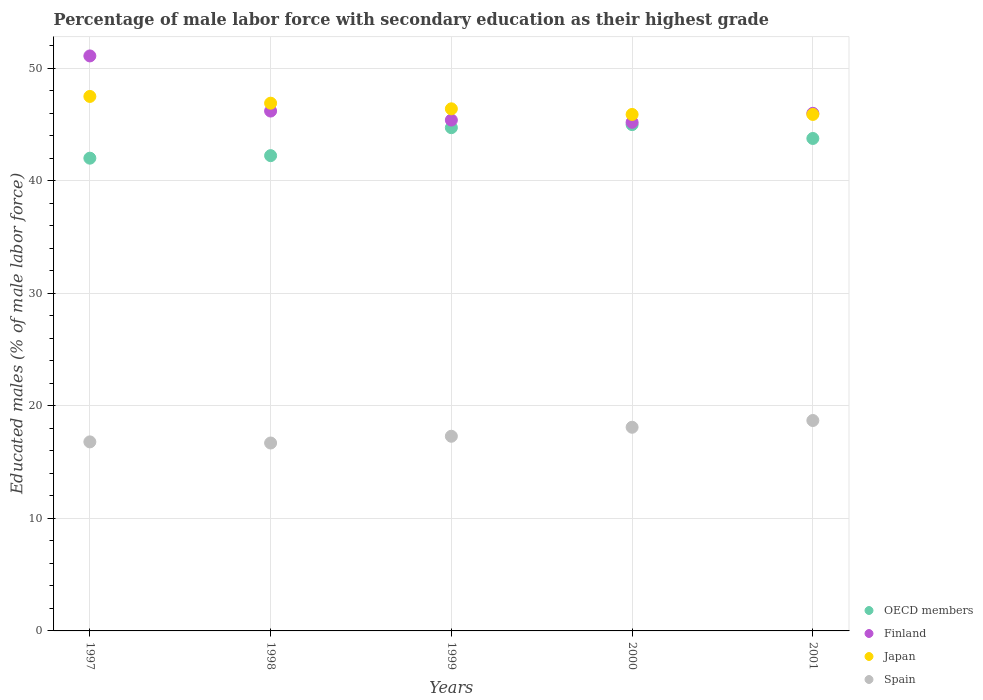How many different coloured dotlines are there?
Your answer should be very brief. 4. Is the number of dotlines equal to the number of legend labels?
Make the answer very short. Yes. What is the percentage of male labor force with secondary education in Spain in 1998?
Provide a short and direct response. 16.7. Across all years, what is the maximum percentage of male labor force with secondary education in Finland?
Ensure brevity in your answer.  51.1. Across all years, what is the minimum percentage of male labor force with secondary education in Finland?
Provide a short and direct response. 45.2. What is the total percentage of male labor force with secondary education in Japan in the graph?
Make the answer very short. 232.6. What is the difference between the percentage of male labor force with secondary education in Spain in 1997 and that in 1998?
Give a very brief answer. 0.1. What is the difference between the percentage of male labor force with secondary education in Finland in 1998 and the percentage of male labor force with secondary education in Spain in 1999?
Offer a terse response. 28.9. What is the average percentage of male labor force with secondary education in OECD members per year?
Give a very brief answer. 43.55. In the year 1997, what is the difference between the percentage of male labor force with secondary education in Japan and percentage of male labor force with secondary education in Finland?
Your response must be concise. -3.6. In how many years, is the percentage of male labor force with secondary education in Spain greater than 20 %?
Your answer should be very brief. 0. What is the ratio of the percentage of male labor force with secondary education in Japan in 1997 to that in 1998?
Your response must be concise. 1.01. Is the difference between the percentage of male labor force with secondary education in Japan in 1999 and 2001 greater than the difference between the percentage of male labor force with secondary education in Finland in 1999 and 2001?
Give a very brief answer. Yes. What is the difference between the highest and the second highest percentage of male labor force with secondary education in Japan?
Keep it short and to the point. 0.6. What is the difference between the highest and the lowest percentage of male labor force with secondary education in OECD members?
Your response must be concise. 2.98. In how many years, is the percentage of male labor force with secondary education in Japan greater than the average percentage of male labor force with secondary education in Japan taken over all years?
Give a very brief answer. 2. Is the sum of the percentage of male labor force with secondary education in Spain in 1999 and 2001 greater than the maximum percentage of male labor force with secondary education in OECD members across all years?
Provide a short and direct response. No. Is it the case that in every year, the sum of the percentage of male labor force with secondary education in Japan and percentage of male labor force with secondary education in OECD members  is greater than the percentage of male labor force with secondary education in Finland?
Keep it short and to the point. Yes. Is the percentage of male labor force with secondary education in Finland strictly greater than the percentage of male labor force with secondary education in Japan over the years?
Ensure brevity in your answer.  No. Is the percentage of male labor force with secondary education in Japan strictly less than the percentage of male labor force with secondary education in Spain over the years?
Make the answer very short. No. How many dotlines are there?
Make the answer very short. 4. How many years are there in the graph?
Make the answer very short. 5. What is the difference between two consecutive major ticks on the Y-axis?
Provide a short and direct response. 10. Are the values on the major ticks of Y-axis written in scientific E-notation?
Keep it short and to the point. No. Does the graph contain any zero values?
Provide a succinct answer. No. Does the graph contain grids?
Give a very brief answer. Yes. How are the legend labels stacked?
Your answer should be compact. Vertical. What is the title of the graph?
Give a very brief answer. Percentage of male labor force with secondary education as their highest grade. What is the label or title of the Y-axis?
Your response must be concise. Educated males (% of male labor force). What is the Educated males (% of male labor force) of OECD members in 1997?
Give a very brief answer. 42.01. What is the Educated males (% of male labor force) of Finland in 1997?
Offer a very short reply. 51.1. What is the Educated males (% of male labor force) in Japan in 1997?
Keep it short and to the point. 47.5. What is the Educated males (% of male labor force) in Spain in 1997?
Your answer should be very brief. 16.8. What is the Educated males (% of male labor force) in OECD members in 1998?
Offer a very short reply. 42.24. What is the Educated males (% of male labor force) of Finland in 1998?
Give a very brief answer. 46.2. What is the Educated males (% of male labor force) in Japan in 1998?
Offer a terse response. 46.9. What is the Educated males (% of male labor force) of Spain in 1998?
Keep it short and to the point. 16.7. What is the Educated males (% of male labor force) in OECD members in 1999?
Ensure brevity in your answer.  44.72. What is the Educated males (% of male labor force) of Finland in 1999?
Make the answer very short. 45.4. What is the Educated males (% of male labor force) of Japan in 1999?
Keep it short and to the point. 46.4. What is the Educated males (% of male labor force) in Spain in 1999?
Your answer should be very brief. 17.3. What is the Educated males (% of male labor force) of OECD members in 2000?
Your response must be concise. 45. What is the Educated males (% of male labor force) of Finland in 2000?
Give a very brief answer. 45.2. What is the Educated males (% of male labor force) of Japan in 2000?
Offer a terse response. 45.9. What is the Educated males (% of male labor force) of Spain in 2000?
Give a very brief answer. 18.1. What is the Educated males (% of male labor force) of OECD members in 2001?
Give a very brief answer. 43.76. What is the Educated males (% of male labor force) of Finland in 2001?
Offer a very short reply. 46. What is the Educated males (% of male labor force) in Japan in 2001?
Provide a short and direct response. 45.9. What is the Educated males (% of male labor force) of Spain in 2001?
Your response must be concise. 18.7. Across all years, what is the maximum Educated males (% of male labor force) of OECD members?
Make the answer very short. 45. Across all years, what is the maximum Educated males (% of male labor force) of Finland?
Give a very brief answer. 51.1. Across all years, what is the maximum Educated males (% of male labor force) of Japan?
Offer a very short reply. 47.5. Across all years, what is the maximum Educated males (% of male labor force) of Spain?
Provide a short and direct response. 18.7. Across all years, what is the minimum Educated males (% of male labor force) in OECD members?
Provide a short and direct response. 42.01. Across all years, what is the minimum Educated males (% of male labor force) in Finland?
Keep it short and to the point. 45.2. Across all years, what is the minimum Educated males (% of male labor force) in Japan?
Provide a short and direct response. 45.9. Across all years, what is the minimum Educated males (% of male labor force) in Spain?
Offer a very short reply. 16.7. What is the total Educated males (% of male labor force) in OECD members in the graph?
Offer a very short reply. 217.73. What is the total Educated males (% of male labor force) in Finland in the graph?
Your answer should be compact. 233.9. What is the total Educated males (% of male labor force) of Japan in the graph?
Offer a terse response. 232.6. What is the total Educated males (% of male labor force) in Spain in the graph?
Your response must be concise. 87.6. What is the difference between the Educated males (% of male labor force) of OECD members in 1997 and that in 1998?
Provide a succinct answer. -0.22. What is the difference between the Educated males (% of male labor force) of Finland in 1997 and that in 1998?
Keep it short and to the point. 4.9. What is the difference between the Educated males (% of male labor force) of Japan in 1997 and that in 1998?
Keep it short and to the point. 0.6. What is the difference between the Educated males (% of male labor force) of OECD members in 1997 and that in 1999?
Your answer should be very brief. -2.71. What is the difference between the Educated males (% of male labor force) in Spain in 1997 and that in 1999?
Provide a short and direct response. -0.5. What is the difference between the Educated males (% of male labor force) in OECD members in 1997 and that in 2000?
Offer a terse response. -2.98. What is the difference between the Educated males (% of male labor force) in OECD members in 1997 and that in 2001?
Offer a very short reply. -1.75. What is the difference between the Educated males (% of male labor force) in Spain in 1997 and that in 2001?
Ensure brevity in your answer.  -1.9. What is the difference between the Educated males (% of male labor force) of OECD members in 1998 and that in 1999?
Keep it short and to the point. -2.49. What is the difference between the Educated males (% of male labor force) in Finland in 1998 and that in 1999?
Your answer should be compact. 0.8. What is the difference between the Educated males (% of male labor force) of Spain in 1998 and that in 1999?
Make the answer very short. -0.6. What is the difference between the Educated males (% of male labor force) in OECD members in 1998 and that in 2000?
Offer a terse response. -2.76. What is the difference between the Educated males (% of male labor force) in Spain in 1998 and that in 2000?
Make the answer very short. -1.4. What is the difference between the Educated males (% of male labor force) of OECD members in 1998 and that in 2001?
Your answer should be very brief. -1.53. What is the difference between the Educated males (% of male labor force) of Finland in 1998 and that in 2001?
Give a very brief answer. 0.2. What is the difference between the Educated males (% of male labor force) of OECD members in 1999 and that in 2000?
Offer a very short reply. -0.27. What is the difference between the Educated males (% of male labor force) of Japan in 1999 and that in 2000?
Offer a very short reply. 0.5. What is the difference between the Educated males (% of male labor force) of Spain in 1999 and that in 2000?
Ensure brevity in your answer.  -0.8. What is the difference between the Educated males (% of male labor force) in Finland in 1999 and that in 2001?
Your response must be concise. -0.6. What is the difference between the Educated males (% of male labor force) in Japan in 1999 and that in 2001?
Make the answer very short. 0.5. What is the difference between the Educated males (% of male labor force) of Spain in 1999 and that in 2001?
Offer a terse response. -1.4. What is the difference between the Educated males (% of male labor force) in OECD members in 2000 and that in 2001?
Your answer should be very brief. 1.23. What is the difference between the Educated males (% of male labor force) in Finland in 2000 and that in 2001?
Make the answer very short. -0.8. What is the difference between the Educated males (% of male labor force) in OECD members in 1997 and the Educated males (% of male labor force) in Finland in 1998?
Offer a terse response. -4.19. What is the difference between the Educated males (% of male labor force) in OECD members in 1997 and the Educated males (% of male labor force) in Japan in 1998?
Offer a very short reply. -4.89. What is the difference between the Educated males (% of male labor force) of OECD members in 1997 and the Educated males (% of male labor force) of Spain in 1998?
Offer a terse response. 25.31. What is the difference between the Educated males (% of male labor force) of Finland in 1997 and the Educated males (% of male labor force) of Japan in 1998?
Provide a short and direct response. 4.2. What is the difference between the Educated males (% of male labor force) in Finland in 1997 and the Educated males (% of male labor force) in Spain in 1998?
Ensure brevity in your answer.  34.4. What is the difference between the Educated males (% of male labor force) of Japan in 1997 and the Educated males (% of male labor force) of Spain in 1998?
Your answer should be compact. 30.8. What is the difference between the Educated males (% of male labor force) of OECD members in 1997 and the Educated males (% of male labor force) of Finland in 1999?
Make the answer very short. -3.39. What is the difference between the Educated males (% of male labor force) of OECD members in 1997 and the Educated males (% of male labor force) of Japan in 1999?
Your answer should be very brief. -4.39. What is the difference between the Educated males (% of male labor force) in OECD members in 1997 and the Educated males (% of male labor force) in Spain in 1999?
Offer a very short reply. 24.71. What is the difference between the Educated males (% of male labor force) in Finland in 1997 and the Educated males (% of male labor force) in Spain in 1999?
Make the answer very short. 33.8. What is the difference between the Educated males (% of male labor force) of Japan in 1997 and the Educated males (% of male labor force) of Spain in 1999?
Your answer should be very brief. 30.2. What is the difference between the Educated males (% of male labor force) of OECD members in 1997 and the Educated males (% of male labor force) of Finland in 2000?
Provide a succinct answer. -3.19. What is the difference between the Educated males (% of male labor force) of OECD members in 1997 and the Educated males (% of male labor force) of Japan in 2000?
Keep it short and to the point. -3.89. What is the difference between the Educated males (% of male labor force) of OECD members in 1997 and the Educated males (% of male labor force) of Spain in 2000?
Offer a very short reply. 23.91. What is the difference between the Educated males (% of male labor force) of Japan in 1997 and the Educated males (% of male labor force) of Spain in 2000?
Provide a short and direct response. 29.4. What is the difference between the Educated males (% of male labor force) of OECD members in 1997 and the Educated males (% of male labor force) of Finland in 2001?
Provide a short and direct response. -3.99. What is the difference between the Educated males (% of male labor force) in OECD members in 1997 and the Educated males (% of male labor force) in Japan in 2001?
Ensure brevity in your answer.  -3.89. What is the difference between the Educated males (% of male labor force) in OECD members in 1997 and the Educated males (% of male labor force) in Spain in 2001?
Your response must be concise. 23.31. What is the difference between the Educated males (% of male labor force) in Finland in 1997 and the Educated males (% of male labor force) in Japan in 2001?
Make the answer very short. 5.2. What is the difference between the Educated males (% of male labor force) of Finland in 1997 and the Educated males (% of male labor force) of Spain in 2001?
Offer a very short reply. 32.4. What is the difference between the Educated males (% of male labor force) in Japan in 1997 and the Educated males (% of male labor force) in Spain in 2001?
Give a very brief answer. 28.8. What is the difference between the Educated males (% of male labor force) of OECD members in 1998 and the Educated males (% of male labor force) of Finland in 1999?
Provide a succinct answer. -3.16. What is the difference between the Educated males (% of male labor force) in OECD members in 1998 and the Educated males (% of male labor force) in Japan in 1999?
Make the answer very short. -4.16. What is the difference between the Educated males (% of male labor force) of OECD members in 1998 and the Educated males (% of male labor force) of Spain in 1999?
Ensure brevity in your answer.  24.94. What is the difference between the Educated males (% of male labor force) of Finland in 1998 and the Educated males (% of male labor force) of Japan in 1999?
Provide a succinct answer. -0.2. What is the difference between the Educated males (% of male labor force) of Finland in 1998 and the Educated males (% of male labor force) of Spain in 1999?
Keep it short and to the point. 28.9. What is the difference between the Educated males (% of male labor force) in Japan in 1998 and the Educated males (% of male labor force) in Spain in 1999?
Provide a short and direct response. 29.6. What is the difference between the Educated males (% of male labor force) of OECD members in 1998 and the Educated males (% of male labor force) of Finland in 2000?
Offer a very short reply. -2.96. What is the difference between the Educated males (% of male labor force) in OECD members in 1998 and the Educated males (% of male labor force) in Japan in 2000?
Offer a terse response. -3.66. What is the difference between the Educated males (% of male labor force) in OECD members in 1998 and the Educated males (% of male labor force) in Spain in 2000?
Offer a very short reply. 24.14. What is the difference between the Educated males (% of male labor force) of Finland in 1998 and the Educated males (% of male labor force) of Japan in 2000?
Offer a very short reply. 0.3. What is the difference between the Educated males (% of male labor force) in Finland in 1998 and the Educated males (% of male labor force) in Spain in 2000?
Offer a terse response. 28.1. What is the difference between the Educated males (% of male labor force) in Japan in 1998 and the Educated males (% of male labor force) in Spain in 2000?
Your answer should be compact. 28.8. What is the difference between the Educated males (% of male labor force) in OECD members in 1998 and the Educated males (% of male labor force) in Finland in 2001?
Offer a very short reply. -3.76. What is the difference between the Educated males (% of male labor force) of OECD members in 1998 and the Educated males (% of male labor force) of Japan in 2001?
Make the answer very short. -3.66. What is the difference between the Educated males (% of male labor force) of OECD members in 1998 and the Educated males (% of male labor force) of Spain in 2001?
Your response must be concise. 23.54. What is the difference between the Educated males (% of male labor force) in Finland in 1998 and the Educated males (% of male labor force) in Spain in 2001?
Offer a terse response. 27.5. What is the difference between the Educated males (% of male labor force) in Japan in 1998 and the Educated males (% of male labor force) in Spain in 2001?
Your answer should be compact. 28.2. What is the difference between the Educated males (% of male labor force) of OECD members in 1999 and the Educated males (% of male labor force) of Finland in 2000?
Provide a succinct answer. -0.48. What is the difference between the Educated males (% of male labor force) of OECD members in 1999 and the Educated males (% of male labor force) of Japan in 2000?
Make the answer very short. -1.18. What is the difference between the Educated males (% of male labor force) in OECD members in 1999 and the Educated males (% of male labor force) in Spain in 2000?
Your answer should be compact. 26.62. What is the difference between the Educated males (% of male labor force) of Finland in 1999 and the Educated males (% of male labor force) of Japan in 2000?
Your answer should be very brief. -0.5. What is the difference between the Educated males (% of male labor force) of Finland in 1999 and the Educated males (% of male labor force) of Spain in 2000?
Your response must be concise. 27.3. What is the difference between the Educated males (% of male labor force) of Japan in 1999 and the Educated males (% of male labor force) of Spain in 2000?
Provide a succinct answer. 28.3. What is the difference between the Educated males (% of male labor force) of OECD members in 1999 and the Educated males (% of male labor force) of Finland in 2001?
Offer a very short reply. -1.28. What is the difference between the Educated males (% of male labor force) in OECD members in 1999 and the Educated males (% of male labor force) in Japan in 2001?
Ensure brevity in your answer.  -1.18. What is the difference between the Educated males (% of male labor force) of OECD members in 1999 and the Educated males (% of male labor force) of Spain in 2001?
Your response must be concise. 26.02. What is the difference between the Educated males (% of male labor force) in Finland in 1999 and the Educated males (% of male labor force) in Spain in 2001?
Offer a terse response. 26.7. What is the difference between the Educated males (% of male labor force) of Japan in 1999 and the Educated males (% of male labor force) of Spain in 2001?
Your answer should be compact. 27.7. What is the difference between the Educated males (% of male labor force) in OECD members in 2000 and the Educated males (% of male labor force) in Finland in 2001?
Keep it short and to the point. -1. What is the difference between the Educated males (% of male labor force) of OECD members in 2000 and the Educated males (% of male labor force) of Japan in 2001?
Keep it short and to the point. -0.9. What is the difference between the Educated males (% of male labor force) of OECD members in 2000 and the Educated males (% of male labor force) of Spain in 2001?
Ensure brevity in your answer.  26.3. What is the difference between the Educated males (% of male labor force) of Finland in 2000 and the Educated males (% of male labor force) of Japan in 2001?
Your answer should be compact. -0.7. What is the difference between the Educated males (% of male labor force) in Japan in 2000 and the Educated males (% of male labor force) in Spain in 2001?
Make the answer very short. 27.2. What is the average Educated males (% of male labor force) in OECD members per year?
Make the answer very short. 43.55. What is the average Educated males (% of male labor force) in Finland per year?
Your response must be concise. 46.78. What is the average Educated males (% of male labor force) in Japan per year?
Keep it short and to the point. 46.52. What is the average Educated males (% of male labor force) of Spain per year?
Keep it short and to the point. 17.52. In the year 1997, what is the difference between the Educated males (% of male labor force) in OECD members and Educated males (% of male labor force) in Finland?
Offer a very short reply. -9.09. In the year 1997, what is the difference between the Educated males (% of male labor force) in OECD members and Educated males (% of male labor force) in Japan?
Keep it short and to the point. -5.49. In the year 1997, what is the difference between the Educated males (% of male labor force) of OECD members and Educated males (% of male labor force) of Spain?
Provide a succinct answer. 25.21. In the year 1997, what is the difference between the Educated males (% of male labor force) of Finland and Educated males (% of male labor force) of Japan?
Your answer should be very brief. 3.6. In the year 1997, what is the difference between the Educated males (% of male labor force) in Finland and Educated males (% of male labor force) in Spain?
Provide a succinct answer. 34.3. In the year 1997, what is the difference between the Educated males (% of male labor force) in Japan and Educated males (% of male labor force) in Spain?
Offer a terse response. 30.7. In the year 1998, what is the difference between the Educated males (% of male labor force) in OECD members and Educated males (% of male labor force) in Finland?
Your answer should be compact. -3.96. In the year 1998, what is the difference between the Educated males (% of male labor force) of OECD members and Educated males (% of male labor force) of Japan?
Provide a short and direct response. -4.66. In the year 1998, what is the difference between the Educated males (% of male labor force) of OECD members and Educated males (% of male labor force) of Spain?
Provide a succinct answer. 25.54. In the year 1998, what is the difference between the Educated males (% of male labor force) in Finland and Educated males (% of male labor force) in Spain?
Your response must be concise. 29.5. In the year 1998, what is the difference between the Educated males (% of male labor force) of Japan and Educated males (% of male labor force) of Spain?
Your answer should be compact. 30.2. In the year 1999, what is the difference between the Educated males (% of male labor force) in OECD members and Educated males (% of male labor force) in Finland?
Your answer should be compact. -0.68. In the year 1999, what is the difference between the Educated males (% of male labor force) of OECD members and Educated males (% of male labor force) of Japan?
Ensure brevity in your answer.  -1.68. In the year 1999, what is the difference between the Educated males (% of male labor force) in OECD members and Educated males (% of male labor force) in Spain?
Offer a terse response. 27.42. In the year 1999, what is the difference between the Educated males (% of male labor force) in Finland and Educated males (% of male labor force) in Spain?
Provide a succinct answer. 28.1. In the year 1999, what is the difference between the Educated males (% of male labor force) of Japan and Educated males (% of male labor force) of Spain?
Keep it short and to the point. 29.1. In the year 2000, what is the difference between the Educated males (% of male labor force) in OECD members and Educated males (% of male labor force) in Finland?
Your answer should be very brief. -0.2. In the year 2000, what is the difference between the Educated males (% of male labor force) of OECD members and Educated males (% of male labor force) of Japan?
Your answer should be very brief. -0.9. In the year 2000, what is the difference between the Educated males (% of male labor force) in OECD members and Educated males (% of male labor force) in Spain?
Offer a very short reply. 26.9. In the year 2000, what is the difference between the Educated males (% of male labor force) in Finland and Educated males (% of male labor force) in Spain?
Ensure brevity in your answer.  27.1. In the year 2000, what is the difference between the Educated males (% of male labor force) of Japan and Educated males (% of male labor force) of Spain?
Provide a short and direct response. 27.8. In the year 2001, what is the difference between the Educated males (% of male labor force) of OECD members and Educated males (% of male labor force) of Finland?
Offer a terse response. -2.24. In the year 2001, what is the difference between the Educated males (% of male labor force) in OECD members and Educated males (% of male labor force) in Japan?
Ensure brevity in your answer.  -2.14. In the year 2001, what is the difference between the Educated males (% of male labor force) in OECD members and Educated males (% of male labor force) in Spain?
Offer a terse response. 25.06. In the year 2001, what is the difference between the Educated males (% of male labor force) in Finland and Educated males (% of male labor force) in Spain?
Keep it short and to the point. 27.3. In the year 2001, what is the difference between the Educated males (% of male labor force) in Japan and Educated males (% of male labor force) in Spain?
Offer a terse response. 27.2. What is the ratio of the Educated males (% of male labor force) of OECD members in 1997 to that in 1998?
Give a very brief answer. 0.99. What is the ratio of the Educated males (% of male labor force) in Finland in 1997 to that in 1998?
Give a very brief answer. 1.11. What is the ratio of the Educated males (% of male labor force) in Japan in 1997 to that in 1998?
Offer a terse response. 1.01. What is the ratio of the Educated males (% of male labor force) in OECD members in 1997 to that in 1999?
Your answer should be very brief. 0.94. What is the ratio of the Educated males (% of male labor force) of Finland in 1997 to that in 1999?
Keep it short and to the point. 1.13. What is the ratio of the Educated males (% of male labor force) of Japan in 1997 to that in 1999?
Keep it short and to the point. 1.02. What is the ratio of the Educated males (% of male labor force) of Spain in 1997 to that in 1999?
Your response must be concise. 0.97. What is the ratio of the Educated males (% of male labor force) of OECD members in 1997 to that in 2000?
Offer a terse response. 0.93. What is the ratio of the Educated males (% of male labor force) of Finland in 1997 to that in 2000?
Give a very brief answer. 1.13. What is the ratio of the Educated males (% of male labor force) of Japan in 1997 to that in 2000?
Offer a very short reply. 1.03. What is the ratio of the Educated males (% of male labor force) of Spain in 1997 to that in 2000?
Your answer should be very brief. 0.93. What is the ratio of the Educated males (% of male labor force) of Finland in 1997 to that in 2001?
Offer a terse response. 1.11. What is the ratio of the Educated males (% of male labor force) of Japan in 1997 to that in 2001?
Offer a very short reply. 1.03. What is the ratio of the Educated males (% of male labor force) in Spain in 1997 to that in 2001?
Provide a succinct answer. 0.9. What is the ratio of the Educated males (% of male labor force) in Finland in 1998 to that in 1999?
Ensure brevity in your answer.  1.02. What is the ratio of the Educated males (% of male labor force) in Japan in 1998 to that in 1999?
Offer a very short reply. 1.01. What is the ratio of the Educated males (% of male labor force) in Spain in 1998 to that in 1999?
Give a very brief answer. 0.97. What is the ratio of the Educated males (% of male labor force) in OECD members in 1998 to that in 2000?
Provide a short and direct response. 0.94. What is the ratio of the Educated males (% of male labor force) in Finland in 1998 to that in 2000?
Offer a very short reply. 1.02. What is the ratio of the Educated males (% of male labor force) in Japan in 1998 to that in 2000?
Make the answer very short. 1.02. What is the ratio of the Educated males (% of male labor force) of Spain in 1998 to that in 2000?
Give a very brief answer. 0.92. What is the ratio of the Educated males (% of male labor force) in OECD members in 1998 to that in 2001?
Offer a very short reply. 0.97. What is the ratio of the Educated males (% of male labor force) in Finland in 1998 to that in 2001?
Provide a succinct answer. 1. What is the ratio of the Educated males (% of male labor force) of Japan in 1998 to that in 2001?
Make the answer very short. 1.02. What is the ratio of the Educated males (% of male labor force) in Spain in 1998 to that in 2001?
Provide a short and direct response. 0.89. What is the ratio of the Educated males (% of male labor force) of OECD members in 1999 to that in 2000?
Give a very brief answer. 0.99. What is the ratio of the Educated males (% of male labor force) in Finland in 1999 to that in 2000?
Ensure brevity in your answer.  1. What is the ratio of the Educated males (% of male labor force) of Japan in 1999 to that in 2000?
Your answer should be compact. 1.01. What is the ratio of the Educated males (% of male labor force) in Spain in 1999 to that in 2000?
Keep it short and to the point. 0.96. What is the ratio of the Educated males (% of male labor force) in OECD members in 1999 to that in 2001?
Provide a succinct answer. 1.02. What is the ratio of the Educated males (% of male labor force) of Finland in 1999 to that in 2001?
Your answer should be compact. 0.99. What is the ratio of the Educated males (% of male labor force) in Japan in 1999 to that in 2001?
Offer a terse response. 1.01. What is the ratio of the Educated males (% of male labor force) of Spain in 1999 to that in 2001?
Provide a short and direct response. 0.93. What is the ratio of the Educated males (% of male labor force) in OECD members in 2000 to that in 2001?
Your answer should be very brief. 1.03. What is the ratio of the Educated males (% of male labor force) in Finland in 2000 to that in 2001?
Your response must be concise. 0.98. What is the ratio of the Educated males (% of male labor force) in Japan in 2000 to that in 2001?
Ensure brevity in your answer.  1. What is the ratio of the Educated males (% of male labor force) of Spain in 2000 to that in 2001?
Offer a very short reply. 0.97. What is the difference between the highest and the second highest Educated males (% of male labor force) in OECD members?
Offer a terse response. 0.27. What is the difference between the highest and the second highest Educated males (% of male labor force) of Finland?
Keep it short and to the point. 4.9. What is the difference between the highest and the lowest Educated males (% of male labor force) in OECD members?
Make the answer very short. 2.98. What is the difference between the highest and the lowest Educated males (% of male labor force) in Japan?
Keep it short and to the point. 1.6. What is the difference between the highest and the lowest Educated males (% of male labor force) of Spain?
Keep it short and to the point. 2. 